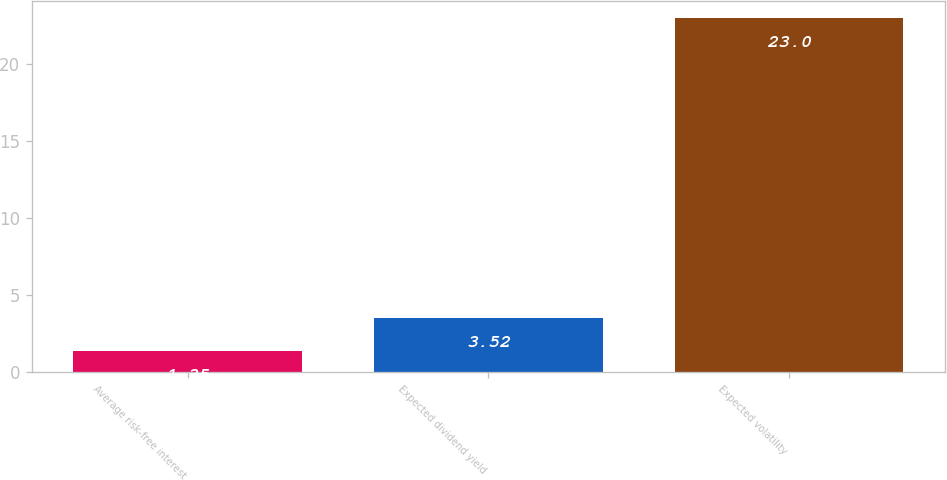<chart> <loc_0><loc_0><loc_500><loc_500><bar_chart><fcel>Average risk-free interest<fcel>Expected dividend yield<fcel>Expected volatility<nl><fcel>1.35<fcel>3.52<fcel>23<nl></chart> 